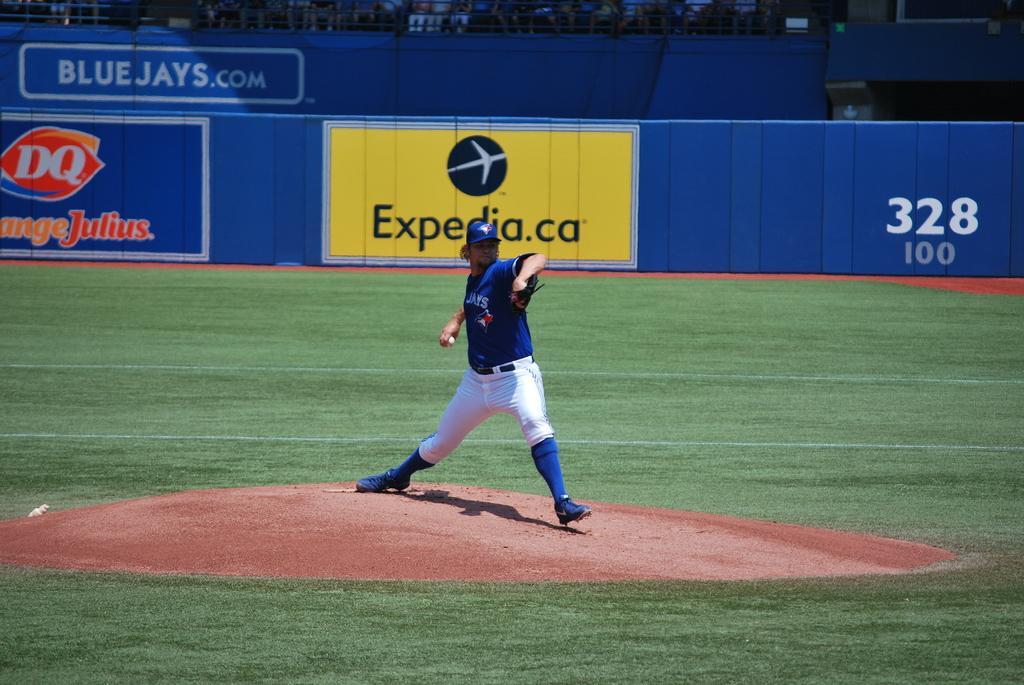What is the teams website?
Give a very brief answer. Bluejays.com. What is the company advertised in yellow?
Give a very brief answer. Expedia. 